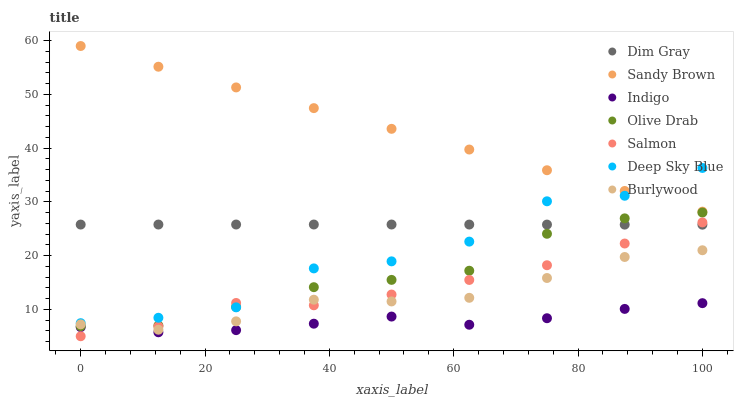Does Indigo have the minimum area under the curve?
Answer yes or no. Yes. Does Sandy Brown have the maximum area under the curve?
Answer yes or no. Yes. Does Burlywood have the minimum area under the curve?
Answer yes or no. No. Does Burlywood have the maximum area under the curve?
Answer yes or no. No. Is Sandy Brown the smoothest?
Answer yes or no. Yes. Is Deep Sky Blue the roughest?
Answer yes or no. Yes. Is Indigo the smoothest?
Answer yes or no. No. Is Indigo the roughest?
Answer yes or no. No. Does Salmon have the lowest value?
Answer yes or no. Yes. Does Indigo have the lowest value?
Answer yes or no. No. Does Sandy Brown have the highest value?
Answer yes or no. Yes. Does Burlywood have the highest value?
Answer yes or no. No. Is Olive Drab less than Sandy Brown?
Answer yes or no. Yes. Is Deep Sky Blue greater than Indigo?
Answer yes or no. Yes. Does Dim Gray intersect Deep Sky Blue?
Answer yes or no. Yes. Is Dim Gray less than Deep Sky Blue?
Answer yes or no. No. Is Dim Gray greater than Deep Sky Blue?
Answer yes or no. No. Does Olive Drab intersect Sandy Brown?
Answer yes or no. No. 